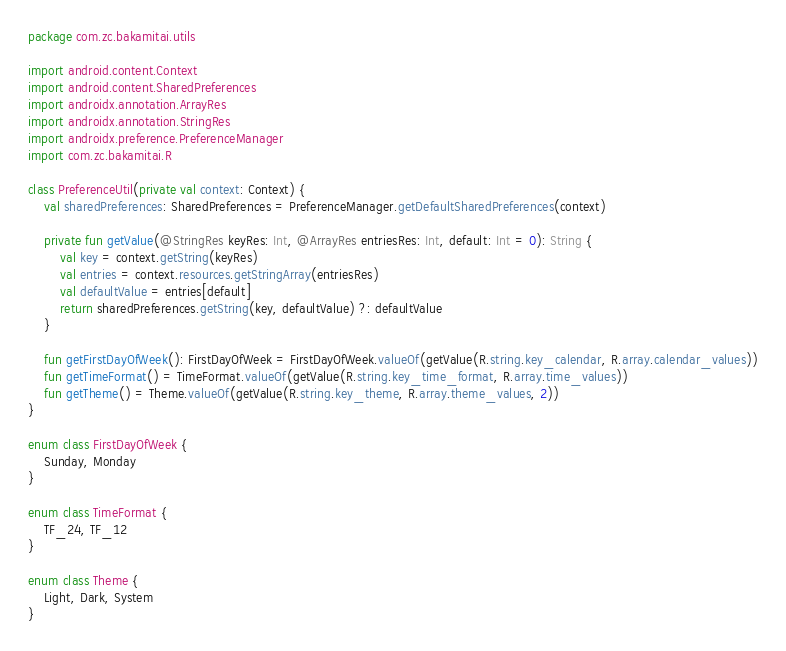Convert code to text. <code><loc_0><loc_0><loc_500><loc_500><_Kotlin_>package com.zc.bakamitai.utils

import android.content.Context
import android.content.SharedPreferences
import androidx.annotation.ArrayRes
import androidx.annotation.StringRes
import androidx.preference.PreferenceManager
import com.zc.bakamitai.R

class PreferenceUtil(private val context: Context) {
    val sharedPreferences: SharedPreferences = PreferenceManager.getDefaultSharedPreferences(context)

    private fun getValue(@StringRes keyRes: Int, @ArrayRes entriesRes: Int, default: Int = 0): String {
        val key = context.getString(keyRes)
        val entries = context.resources.getStringArray(entriesRes)
        val defaultValue = entries[default]
        return sharedPreferences.getString(key, defaultValue) ?: defaultValue
    }

    fun getFirstDayOfWeek(): FirstDayOfWeek = FirstDayOfWeek.valueOf(getValue(R.string.key_calendar, R.array.calendar_values))
    fun getTimeFormat() = TimeFormat.valueOf(getValue(R.string.key_time_format, R.array.time_values))
    fun getTheme() = Theme.valueOf(getValue(R.string.key_theme, R.array.theme_values, 2))
}

enum class FirstDayOfWeek {
    Sunday, Monday
}

enum class TimeFormat {
    TF_24, TF_12
}

enum class Theme {
    Light, Dark, System
}
</code> 